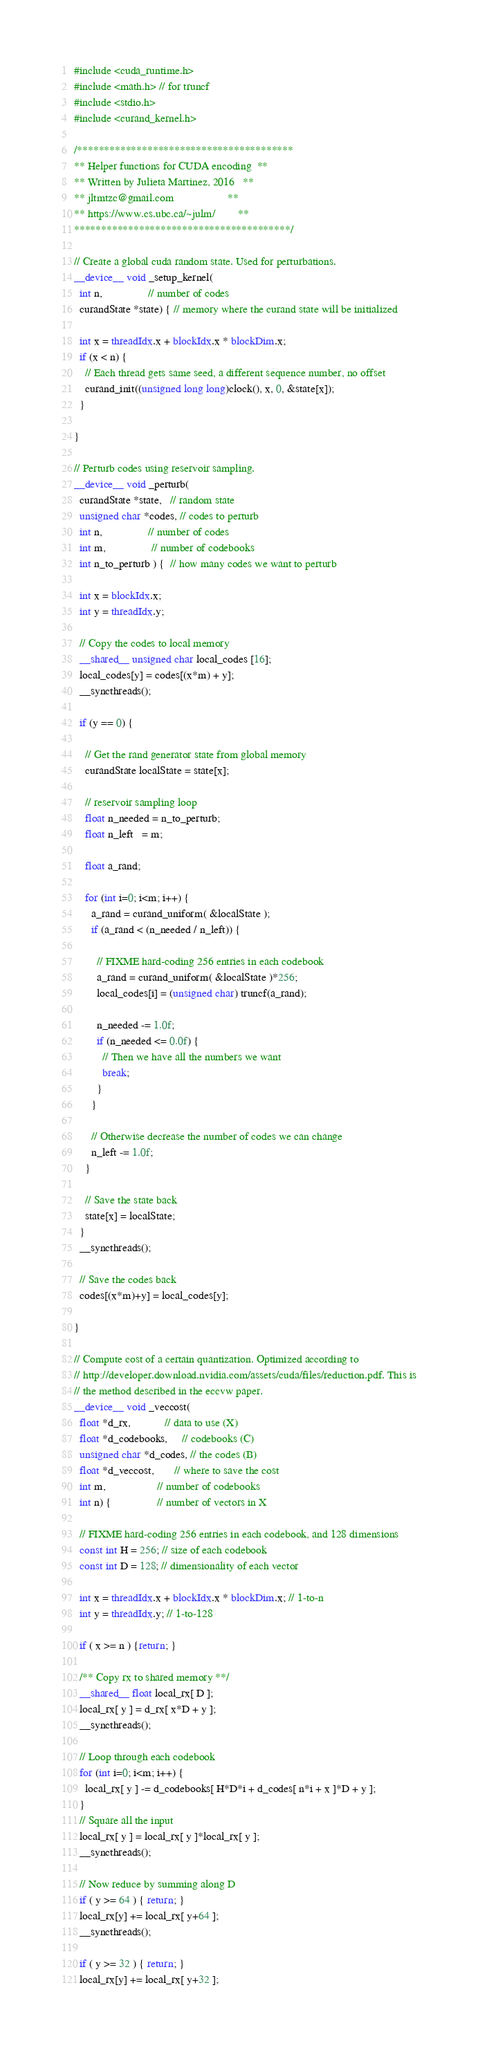<code> <loc_0><loc_0><loc_500><loc_500><_Cuda_>#include <cuda_runtime.h>
#include <math.h> // for truncf
#include <stdio.h>
#include <curand_kernel.h>

/****************************************
** Helper functions for CUDA encoding  **
** Written by Julieta Martinez, 2016   **
** jltmtzc@gmail.com                   **
** https://www.cs.ubc.ca/~julm/        **
****************************************/

// Create a global cuda random state. Used for perturbations.
__device__ void _setup_kernel(
  int n,                // number of codes
  curandState *state) { // memory where the curand state will be initialized

  int x = threadIdx.x + blockIdx.x * blockDim.x;
  if (x < n) {
    // Each thread gets same seed, a different sequence number, no offset
    curand_init((unsigned long long)clock(), x, 0, &state[x]);
  }

}

// Perturb codes using reservoir sampling.
__device__ void _perturb(
  curandState *state,   // random state
  unsigned char *codes, // codes to perturb
  int n,                // number of codes
  int m,                // number of codebooks
  int n_to_perturb ) {  // how many codes we want to perturb

  int x = blockIdx.x;
  int y = threadIdx.y;

  // Copy the codes to local memory
  __shared__ unsigned char local_codes [16];
  local_codes[y] = codes[(x*m) + y];
  __syncthreads();

  if (y == 0) {

    // Get the rand generator state from global memory
    curandState localState = state[x];

    // reservoir sampling loop
    float n_needed = n_to_perturb;
    float n_left   = m;

    float a_rand;

    for (int i=0; i<m; i++) {
      a_rand = curand_uniform( &localState );
      if (a_rand < (n_needed / n_left)) {

        // FIXME hard-coding 256 entries in each codebook
        a_rand = curand_uniform( &localState )*256;
        local_codes[i] = (unsigned char) truncf(a_rand);

        n_needed -= 1.0f;
        if (n_needed <= 0.0f) {
          // Then we have all the numbers we want
          break;
        }
      }

      // Otherwise decrease the number of codes we can change
      n_left -= 1.0f;
    }

    // Save the state back
    state[x] = localState;
  }
  __syncthreads();

  // Save the codes back
  codes[(x*m)+y] = local_codes[y];

}

// Compute cost of a certain quantization. Optimized according to
// http://developer.download.nvidia.com/assets/cuda/files/reduction.pdf. This is
// the method described in the eccvw paper.
__device__ void _veccost(
  float *d_rx,            // data to use (X)
  float *d_codebooks,     // codebooks (C)
  unsigned char *d_codes, // the codes (B)
  float *d_veccost,       // where to save the cost
  int m,                  // number of codebooks
  int n) {                // number of vectors in X

  // FIXME hard-coding 256 entries in each codebook, and 128 dimensions
  const int H = 256; // size of each codebook
  const int D = 128; // dimensionality of each vector

  int x = threadIdx.x + blockIdx.x * blockDim.x; // 1-to-n
  int y = threadIdx.y; // 1-to-128

  if ( x >= n ) {return; }

  /** Copy rx to shared memory **/
  __shared__ float local_rx[ D ];
  local_rx[ y ] = d_rx[ x*D + y ];
  __syncthreads();

  // Loop through each codebook
  for (int i=0; i<m; i++) {
    local_rx[ y ] -= d_codebooks[ H*D*i + d_codes[ n*i + x ]*D + y ];
  }
  // Square all the input
  local_rx[ y ] = local_rx[ y ]*local_rx[ y ];
  __syncthreads();

  // Now reduce by summing along D
  if ( y >= 64 ) { return; }
  local_rx[y] += local_rx[ y+64 ];
  __syncthreads();

  if ( y >= 32 ) { return; }
  local_rx[y] += local_rx[ y+32 ];
</code> 